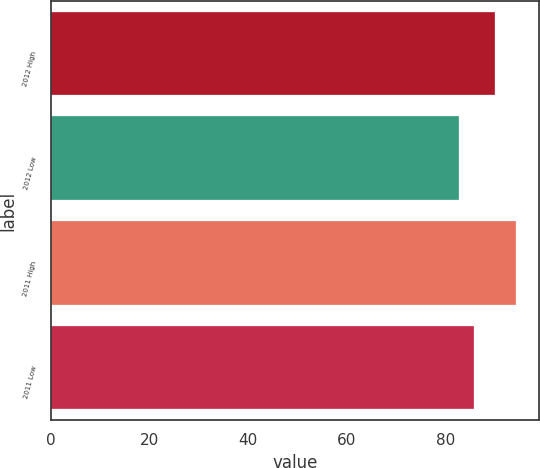<chart> <loc_0><loc_0><loc_500><loc_500><bar_chart><fcel>2012 High<fcel>2012 Low<fcel>2011 High<fcel>2011 Low<nl><fcel>90<fcel>82.7<fcel>94.16<fcel>85.63<nl></chart> 